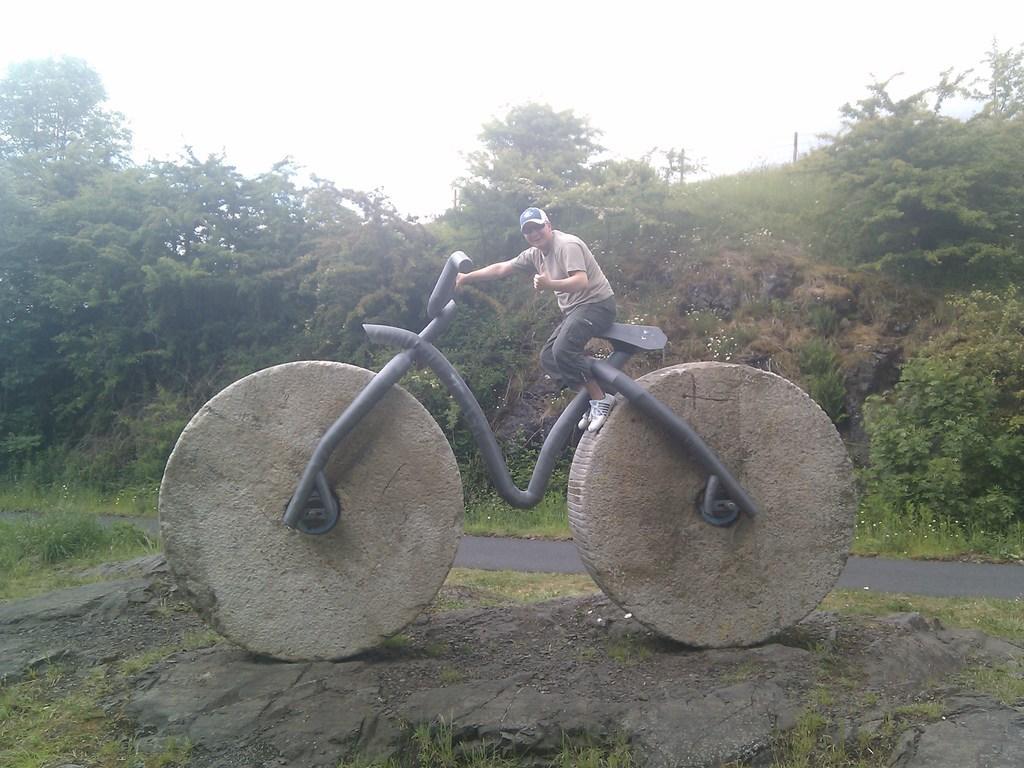How would you summarize this image in a sentence or two? This person is sitting on a statue of a bicycle. Far there are number of trees and plants. 